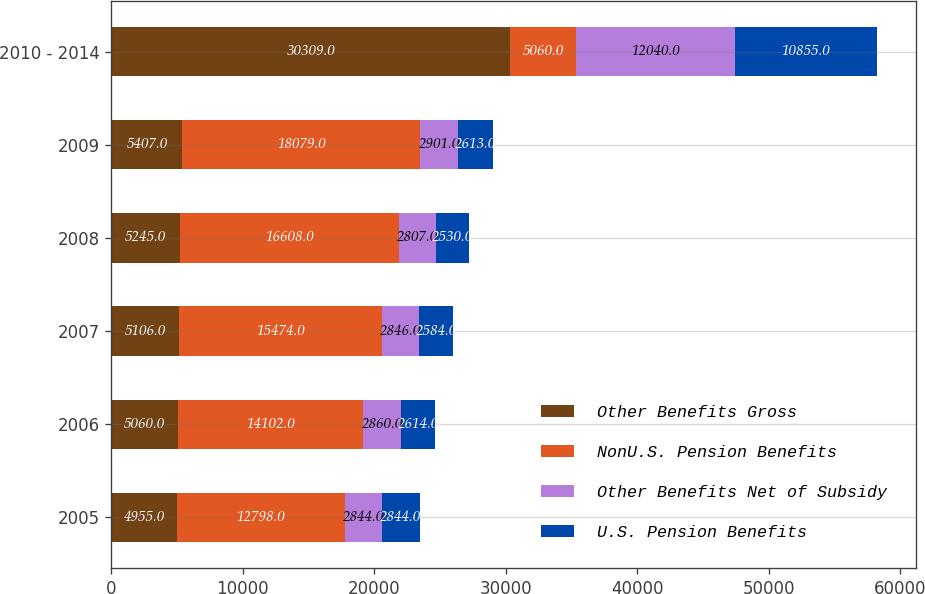<chart> <loc_0><loc_0><loc_500><loc_500><stacked_bar_chart><ecel><fcel>2005<fcel>2006<fcel>2007<fcel>2008<fcel>2009<fcel>2010 - 2014<nl><fcel>Other Benefits Gross<fcel>4955<fcel>5060<fcel>5106<fcel>5245<fcel>5407<fcel>30309<nl><fcel>NonU.S. Pension Benefits<fcel>12798<fcel>14102<fcel>15474<fcel>16608<fcel>18079<fcel>5060<nl><fcel>Other Benefits Net of Subsidy<fcel>2844<fcel>2860<fcel>2846<fcel>2807<fcel>2901<fcel>12040<nl><fcel>U.S. Pension Benefits<fcel>2844<fcel>2614<fcel>2584<fcel>2530<fcel>2613<fcel>10855<nl></chart> 